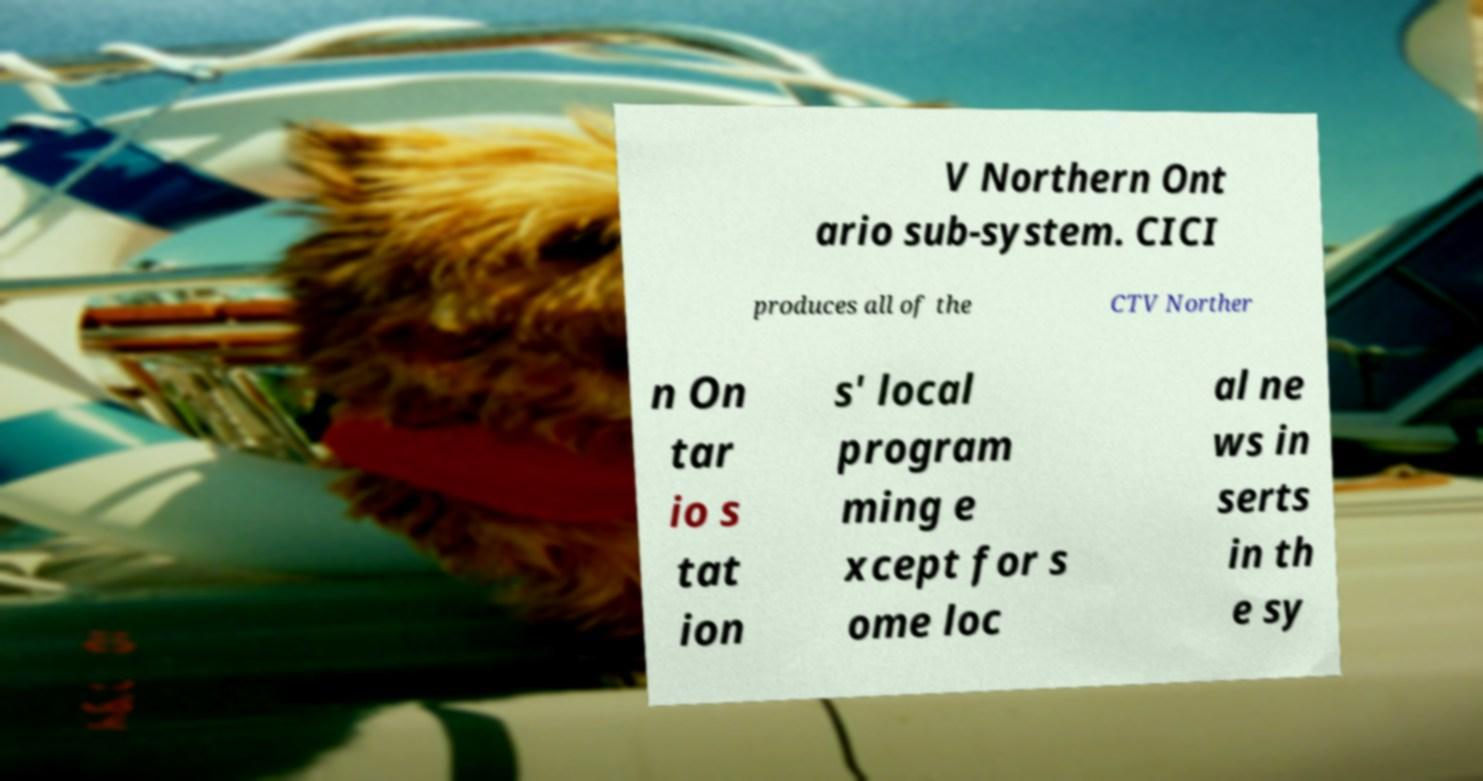Could you assist in decoding the text presented in this image and type it out clearly? V Northern Ont ario sub-system. CICI produces all of the CTV Norther n On tar io s tat ion s' local program ming e xcept for s ome loc al ne ws in serts in th e sy 